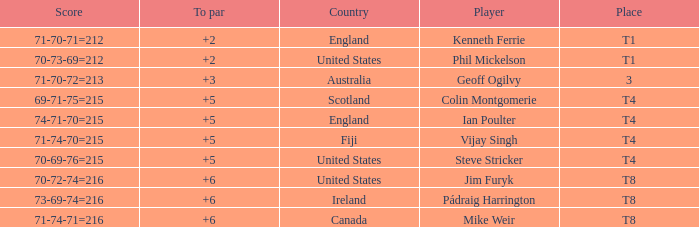What score to highest to par did Mike Weir achieve? 6.0. 